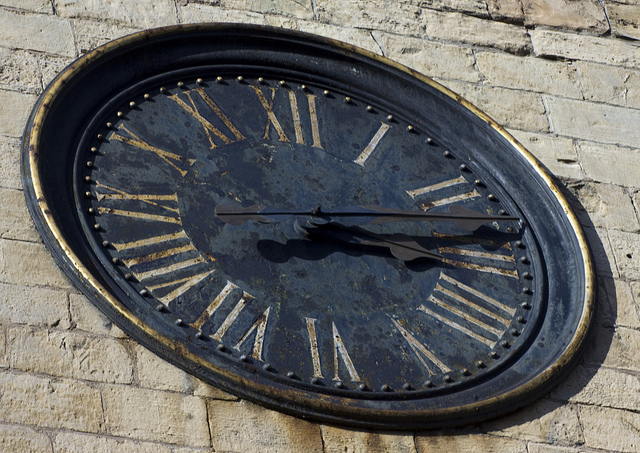How many clocks are there? There is one clock visible in the image. It's an old clock mounted on a wall, featuring Roman numerals and ornate hands, with a sense of history etched into its surface. 